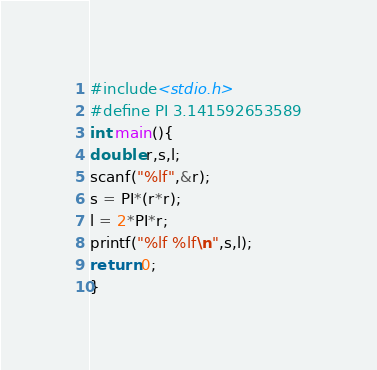Convert code to text. <code><loc_0><loc_0><loc_500><loc_500><_C_>#include<stdio.h>
#define PI 3.141592653589
int main(){
double r,s,l;
scanf("%lf",&r);
s = PI*(r*r);
l = 2*PI*r;
printf("%lf %lf\n",s,l);
return 0;
}</code> 